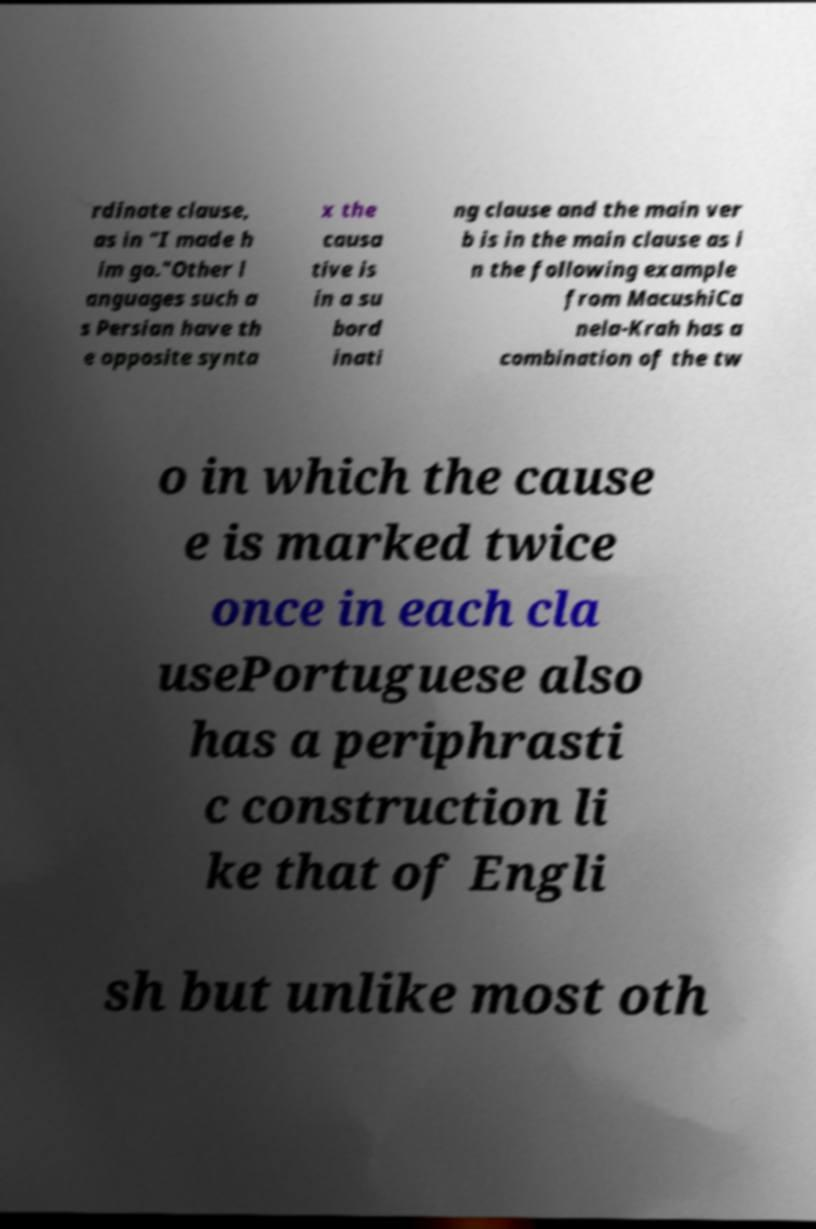Please identify and transcribe the text found in this image. rdinate clause, as in "I made h im go."Other l anguages such a s Persian have th e opposite synta x the causa tive is in a su bord inati ng clause and the main ver b is in the main clause as i n the following example from MacushiCa nela-Krah has a combination of the tw o in which the cause e is marked twice once in each cla usePortuguese also has a periphrasti c construction li ke that of Engli sh but unlike most oth 